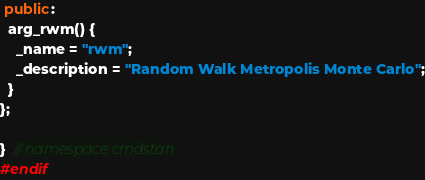Convert code to text. <code><loc_0><loc_0><loc_500><loc_500><_C++_> public:
  arg_rwm() {
    _name = "rwm";
    _description = "Random Walk Metropolis Monte Carlo";
  }
};

}  // namespace cmdstan
#endif
</code> 